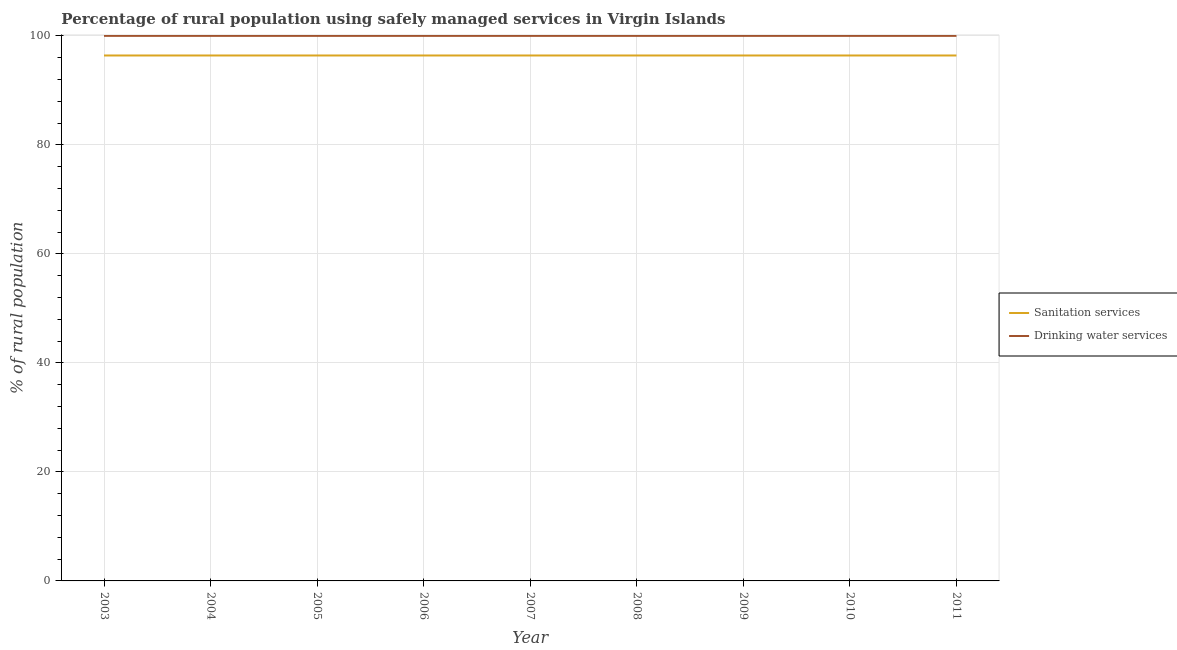Does the line corresponding to percentage of rural population who used drinking water services intersect with the line corresponding to percentage of rural population who used sanitation services?
Offer a very short reply. No. Is the number of lines equal to the number of legend labels?
Give a very brief answer. Yes. What is the percentage of rural population who used sanitation services in 2008?
Your response must be concise. 96.4. Across all years, what is the maximum percentage of rural population who used drinking water services?
Give a very brief answer. 100. Across all years, what is the minimum percentage of rural population who used drinking water services?
Your answer should be compact. 100. In which year was the percentage of rural population who used drinking water services maximum?
Offer a very short reply. 2003. In which year was the percentage of rural population who used drinking water services minimum?
Your answer should be compact. 2003. What is the total percentage of rural population who used drinking water services in the graph?
Your answer should be compact. 900. What is the difference between the percentage of rural population who used drinking water services in 2011 and the percentage of rural population who used sanitation services in 2008?
Provide a short and direct response. 3.6. What is the average percentage of rural population who used drinking water services per year?
Offer a very short reply. 100. In the year 2010, what is the difference between the percentage of rural population who used drinking water services and percentage of rural population who used sanitation services?
Give a very brief answer. 3.6. In how many years, is the percentage of rural population who used sanitation services greater than 80 %?
Your answer should be compact. 9. What is the ratio of the percentage of rural population who used drinking water services in 2006 to that in 2009?
Make the answer very short. 1. What is the difference between the highest and the second highest percentage of rural population who used sanitation services?
Offer a terse response. 0. What is the difference between the highest and the lowest percentage of rural population who used drinking water services?
Your answer should be compact. 0. In how many years, is the percentage of rural population who used sanitation services greater than the average percentage of rural population who used sanitation services taken over all years?
Offer a terse response. 0. Is the percentage of rural population who used sanitation services strictly greater than the percentage of rural population who used drinking water services over the years?
Your answer should be very brief. No. What is the difference between two consecutive major ticks on the Y-axis?
Keep it short and to the point. 20. How many legend labels are there?
Make the answer very short. 2. How are the legend labels stacked?
Offer a very short reply. Vertical. What is the title of the graph?
Give a very brief answer. Percentage of rural population using safely managed services in Virgin Islands. Does "Frequency of shipment arrival" appear as one of the legend labels in the graph?
Keep it short and to the point. No. What is the label or title of the Y-axis?
Your answer should be very brief. % of rural population. What is the % of rural population of Sanitation services in 2003?
Your answer should be compact. 96.4. What is the % of rural population in Sanitation services in 2004?
Offer a terse response. 96.4. What is the % of rural population in Drinking water services in 2004?
Offer a terse response. 100. What is the % of rural population of Sanitation services in 2005?
Your answer should be very brief. 96.4. What is the % of rural population in Sanitation services in 2006?
Offer a very short reply. 96.4. What is the % of rural population of Drinking water services in 2006?
Make the answer very short. 100. What is the % of rural population in Sanitation services in 2007?
Provide a succinct answer. 96.4. What is the % of rural population of Sanitation services in 2008?
Your answer should be very brief. 96.4. What is the % of rural population in Sanitation services in 2009?
Ensure brevity in your answer.  96.4. What is the % of rural population in Sanitation services in 2010?
Offer a very short reply. 96.4. What is the % of rural population of Sanitation services in 2011?
Keep it short and to the point. 96.4. What is the % of rural population of Drinking water services in 2011?
Provide a short and direct response. 100. Across all years, what is the maximum % of rural population in Sanitation services?
Give a very brief answer. 96.4. Across all years, what is the minimum % of rural population in Sanitation services?
Offer a very short reply. 96.4. What is the total % of rural population in Sanitation services in the graph?
Your answer should be compact. 867.6. What is the total % of rural population in Drinking water services in the graph?
Your answer should be very brief. 900. What is the difference between the % of rural population of Drinking water services in 2003 and that in 2004?
Make the answer very short. 0. What is the difference between the % of rural population in Sanitation services in 2003 and that in 2005?
Offer a very short reply. 0. What is the difference between the % of rural population of Drinking water services in 2003 and that in 2005?
Give a very brief answer. 0. What is the difference between the % of rural population in Sanitation services in 2003 and that in 2009?
Offer a terse response. 0. What is the difference between the % of rural population in Drinking water services in 2003 and that in 2009?
Keep it short and to the point. 0. What is the difference between the % of rural population in Sanitation services in 2003 and that in 2011?
Keep it short and to the point. 0. What is the difference between the % of rural population of Drinking water services in 2004 and that in 2005?
Keep it short and to the point. 0. What is the difference between the % of rural population in Sanitation services in 2004 and that in 2006?
Make the answer very short. 0. What is the difference between the % of rural population of Drinking water services in 2004 and that in 2007?
Give a very brief answer. 0. What is the difference between the % of rural population of Sanitation services in 2004 and that in 2008?
Provide a succinct answer. 0. What is the difference between the % of rural population of Drinking water services in 2004 and that in 2008?
Provide a short and direct response. 0. What is the difference between the % of rural population in Drinking water services in 2004 and that in 2009?
Provide a succinct answer. 0. What is the difference between the % of rural population of Drinking water services in 2004 and that in 2010?
Provide a succinct answer. 0. What is the difference between the % of rural population of Drinking water services in 2004 and that in 2011?
Give a very brief answer. 0. What is the difference between the % of rural population of Drinking water services in 2005 and that in 2007?
Your answer should be very brief. 0. What is the difference between the % of rural population of Drinking water services in 2005 and that in 2008?
Your answer should be very brief. 0. What is the difference between the % of rural population in Sanitation services in 2005 and that in 2009?
Your answer should be compact. 0. What is the difference between the % of rural population in Sanitation services in 2005 and that in 2010?
Provide a short and direct response. 0. What is the difference between the % of rural population of Drinking water services in 2005 and that in 2010?
Keep it short and to the point. 0. What is the difference between the % of rural population of Sanitation services in 2005 and that in 2011?
Ensure brevity in your answer.  0. What is the difference between the % of rural population in Drinking water services in 2006 and that in 2008?
Give a very brief answer. 0. What is the difference between the % of rural population of Sanitation services in 2006 and that in 2009?
Provide a short and direct response. 0. What is the difference between the % of rural population in Drinking water services in 2006 and that in 2009?
Your answer should be compact. 0. What is the difference between the % of rural population in Drinking water services in 2007 and that in 2008?
Your answer should be compact. 0. What is the difference between the % of rural population of Sanitation services in 2007 and that in 2009?
Your response must be concise. 0. What is the difference between the % of rural population in Drinking water services in 2007 and that in 2009?
Ensure brevity in your answer.  0. What is the difference between the % of rural population in Drinking water services in 2007 and that in 2010?
Your answer should be compact. 0. What is the difference between the % of rural population of Sanitation services in 2007 and that in 2011?
Your answer should be very brief. 0. What is the difference between the % of rural population of Drinking water services in 2007 and that in 2011?
Your answer should be very brief. 0. What is the difference between the % of rural population of Drinking water services in 2008 and that in 2009?
Your response must be concise. 0. What is the difference between the % of rural population in Sanitation services in 2008 and that in 2010?
Provide a short and direct response. 0. What is the difference between the % of rural population in Sanitation services in 2008 and that in 2011?
Make the answer very short. 0. What is the difference between the % of rural population of Sanitation services in 2009 and that in 2010?
Keep it short and to the point. 0. What is the difference between the % of rural population in Sanitation services in 2009 and that in 2011?
Your answer should be compact. 0. What is the difference between the % of rural population of Drinking water services in 2009 and that in 2011?
Provide a succinct answer. 0. What is the difference between the % of rural population of Drinking water services in 2010 and that in 2011?
Your response must be concise. 0. What is the difference between the % of rural population in Sanitation services in 2003 and the % of rural population in Drinking water services in 2004?
Keep it short and to the point. -3.6. What is the difference between the % of rural population in Sanitation services in 2003 and the % of rural population in Drinking water services in 2005?
Offer a very short reply. -3.6. What is the difference between the % of rural population in Sanitation services in 2003 and the % of rural population in Drinking water services in 2006?
Give a very brief answer. -3.6. What is the difference between the % of rural population in Sanitation services in 2003 and the % of rural population in Drinking water services in 2007?
Offer a very short reply. -3.6. What is the difference between the % of rural population of Sanitation services in 2003 and the % of rural population of Drinking water services in 2010?
Provide a short and direct response. -3.6. What is the difference between the % of rural population in Sanitation services in 2003 and the % of rural population in Drinking water services in 2011?
Give a very brief answer. -3.6. What is the difference between the % of rural population of Sanitation services in 2004 and the % of rural population of Drinking water services in 2005?
Provide a short and direct response. -3.6. What is the difference between the % of rural population in Sanitation services in 2004 and the % of rural population in Drinking water services in 2006?
Ensure brevity in your answer.  -3.6. What is the difference between the % of rural population of Sanitation services in 2004 and the % of rural population of Drinking water services in 2010?
Ensure brevity in your answer.  -3.6. What is the difference between the % of rural population in Sanitation services in 2005 and the % of rural population in Drinking water services in 2006?
Offer a very short reply. -3.6. What is the difference between the % of rural population of Sanitation services in 2005 and the % of rural population of Drinking water services in 2007?
Provide a succinct answer. -3.6. What is the difference between the % of rural population of Sanitation services in 2005 and the % of rural population of Drinking water services in 2008?
Make the answer very short. -3.6. What is the difference between the % of rural population of Sanitation services in 2005 and the % of rural population of Drinking water services in 2010?
Offer a terse response. -3.6. What is the difference between the % of rural population of Sanitation services in 2006 and the % of rural population of Drinking water services in 2009?
Your response must be concise. -3.6. What is the difference between the % of rural population in Sanitation services in 2006 and the % of rural population in Drinking water services in 2010?
Your response must be concise. -3.6. What is the difference between the % of rural population in Sanitation services in 2006 and the % of rural population in Drinking water services in 2011?
Provide a short and direct response. -3.6. What is the difference between the % of rural population of Sanitation services in 2007 and the % of rural population of Drinking water services in 2009?
Your answer should be compact. -3.6. What is the difference between the % of rural population in Sanitation services in 2007 and the % of rural population in Drinking water services in 2010?
Your answer should be compact. -3.6. What is the difference between the % of rural population in Sanitation services in 2008 and the % of rural population in Drinking water services in 2009?
Your answer should be compact. -3.6. What is the difference between the % of rural population in Sanitation services in 2008 and the % of rural population in Drinking water services in 2011?
Offer a very short reply. -3.6. What is the difference between the % of rural population in Sanitation services in 2009 and the % of rural population in Drinking water services in 2010?
Give a very brief answer. -3.6. What is the difference between the % of rural population of Sanitation services in 2009 and the % of rural population of Drinking water services in 2011?
Make the answer very short. -3.6. What is the average % of rural population in Sanitation services per year?
Give a very brief answer. 96.4. In the year 2004, what is the difference between the % of rural population in Sanitation services and % of rural population in Drinking water services?
Offer a very short reply. -3.6. In the year 2007, what is the difference between the % of rural population in Sanitation services and % of rural population in Drinking water services?
Ensure brevity in your answer.  -3.6. In the year 2010, what is the difference between the % of rural population in Sanitation services and % of rural population in Drinking water services?
Keep it short and to the point. -3.6. What is the ratio of the % of rural population in Sanitation services in 2003 to that in 2004?
Offer a very short reply. 1. What is the ratio of the % of rural population of Drinking water services in 2003 to that in 2006?
Your response must be concise. 1. What is the ratio of the % of rural population in Sanitation services in 2003 to that in 2007?
Provide a short and direct response. 1. What is the ratio of the % of rural population in Drinking water services in 2003 to that in 2009?
Provide a succinct answer. 1. What is the ratio of the % of rural population in Sanitation services in 2003 to that in 2010?
Your answer should be very brief. 1. What is the ratio of the % of rural population of Sanitation services in 2003 to that in 2011?
Ensure brevity in your answer.  1. What is the ratio of the % of rural population of Drinking water services in 2003 to that in 2011?
Your response must be concise. 1. What is the ratio of the % of rural population in Drinking water services in 2004 to that in 2005?
Offer a very short reply. 1. What is the ratio of the % of rural population of Sanitation services in 2004 to that in 2006?
Your answer should be very brief. 1. What is the ratio of the % of rural population in Drinking water services in 2004 to that in 2006?
Make the answer very short. 1. What is the ratio of the % of rural population in Drinking water services in 2004 to that in 2007?
Offer a terse response. 1. What is the ratio of the % of rural population in Sanitation services in 2004 to that in 2008?
Keep it short and to the point. 1. What is the ratio of the % of rural population of Drinking water services in 2004 to that in 2008?
Your answer should be compact. 1. What is the ratio of the % of rural population of Drinking water services in 2004 to that in 2009?
Your answer should be compact. 1. What is the ratio of the % of rural population in Sanitation services in 2004 to that in 2010?
Offer a terse response. 1. What is the ratio of the % of rural population of Drinking water services in 2004 to that in 2010?
Provide a succinct answer. 1. What is the ratio of the % of rural population in Drinking water services in 2005 to that in 2006?
Offer a very short reply. 1. What is the ratio of the % of rural population in Sanitation services in 2005 to that in 2009?
Your answer should be very brief. 1. What is the ratio of the % of rural population of Drinking water services in 2005 to that in 2010?
Your answer should be compact. 1. What is the ratio of the % of rural population in Sanitation services in 2005 to that in 2011?
Offer a terse response. 1. What is the ratio of the % of rural population in Drinking water services in 2005 to that in 2011?
Ensure brevity in your answer.  1. What is the ratio of the % of rural population in Drinking water services in 2006 to that in 2007?
Your answer should be compact. 1. What is the ratio of the % of rural population of Drinking water services in 2006 to that in 2008?
Your response must be concise. 1. What is the ratio of the % of rural population in Sanitation services in 2006 to that in 2009?
Your response must be concise. 1. What is the ratio of the % of rural population of Sanitation services in 2006 to that in 2010?
Your answer should be compact. 1. What is the ratio of the % of rural population of Drinking water services in 2006 to that in 2010?
Provide a succinct answer. 1. What is the ratio of the % of rural population of Drinking water services in 2007 to that in 2009?
Your response must be concise. 1. What is the ratio of the % of rural population in Drinking water services in 2007 to that in 2010?
Keep it short and to the point. 1. What is the ratio of the % of rural population in Sanitation services in 2007 to that in 2011?
Offer a terse response. 1. What is the ratio of the % of rural population in Drinking water services in 2007 to that in 2011?
Provide a succinct answer. 1. What is the ratio of the % of rural population in Sanitation services in 2008 to that in 2009?
Give a very brief answer. 1. What is the ratio of the % of rural population in Drinking water services in 2008 to that in 2010?
Provide a short and direct response. 1. What is the ratio of the % of rural population of Drinking water services in 2008 to that in 2011?
Provide a succinct answer. 1. What is the ratio of the % of rural population of Sanitation services in 2009 to that in 2010?
Ensure brevity in your answer.  1. What is the ratio of the % of rural population of Drinking water services in 2009 to that in 2010?
Make the answer very short. 1. What is the ratio of the % of rural population of Sanitation services in 2010 to that in 2011?
Offer a terse response. 1. What is the ratio of the % of rural population in Drinking water services in 2010 to that in 2011?
Offer a very short reply. 1. What is the difference between the highest and the lowest % of rural population in Sanitation services?
Ensure brevity in your answer.  0. 